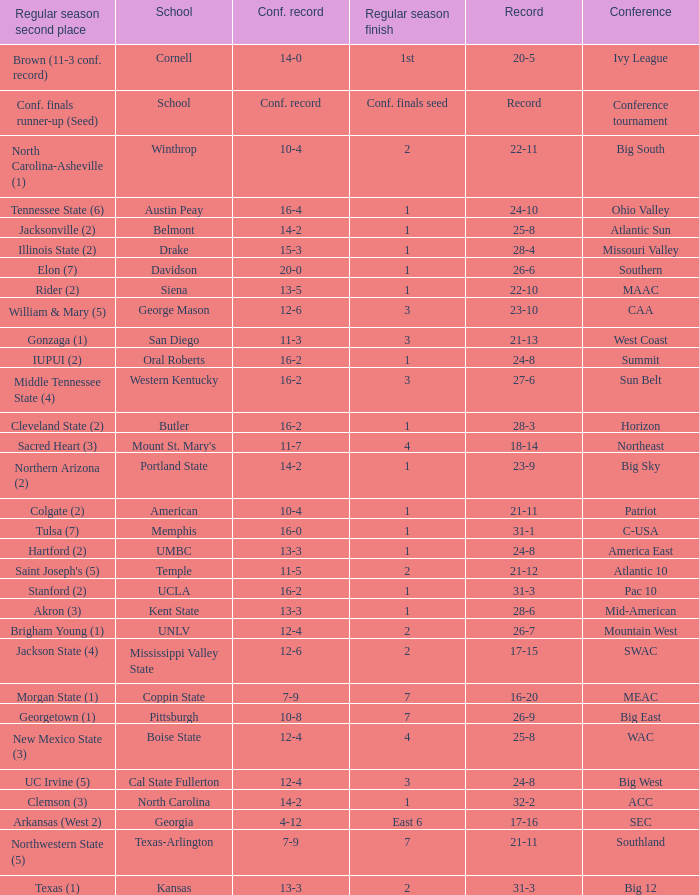For teams in the Sun Belt conference, what is the conference record? 16-2. 